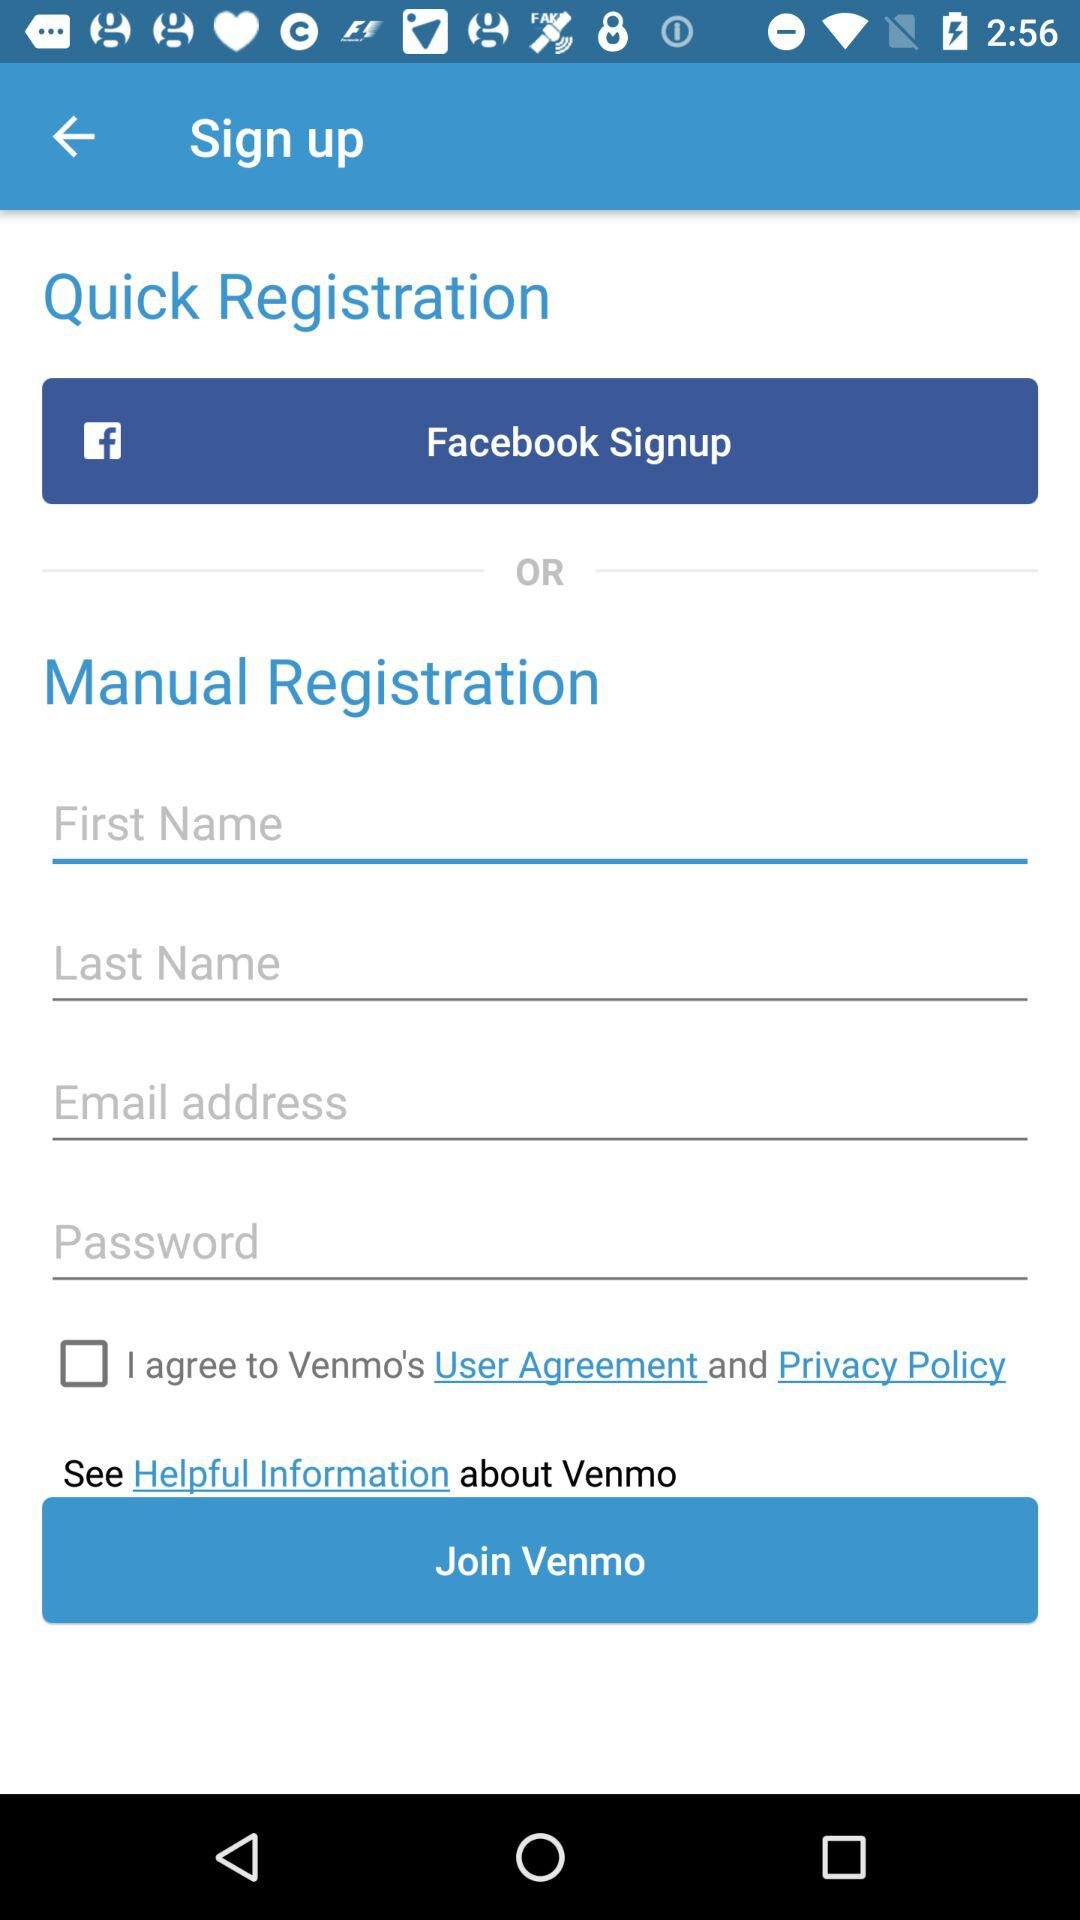Which email address is used for registration?
When the provided information is insufficient, respond with <no answer>. <no answer> 